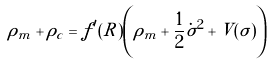<formula> <loc_0><loc_0><loc_500><loc_500>\rho _ { m } + \rho _ { c } = f ^ { \prime } ( R ) \left ( \rho _ { m } + \frac { 1 } { 2 } \dot { \sigma } ^ { 2 } + V ( \sigma ) \right )</formula> 